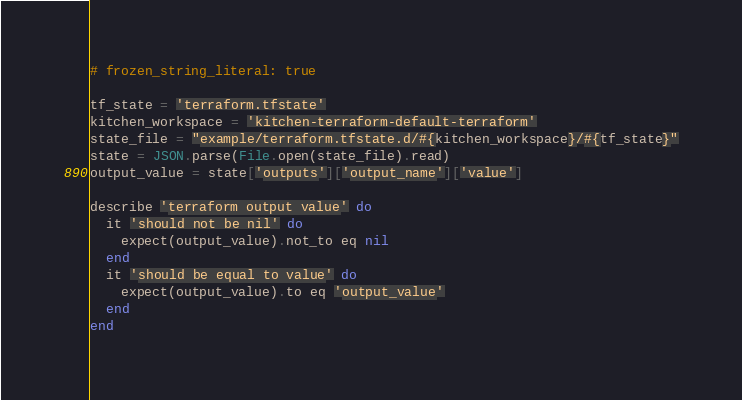Convert code to text. <code><loc_0><loc_0><loc_500><loc_500><_Ruby_># frozen_string_literal: true

tf_state = 'terraform.tfstate'
kitchen_workspace = 'kitchen-terraform-default-terraform'
state_file = "example/terraform.tfstate.d/#{kitchen_workspace}/#{tf_state}"
state = JSON.parse(File.open(state_file).read)
output_value = state['outputs']['output_name']['value']

describe 'terraform output value' do
  it 'should not be nil' do
    expect(output_value).not_to eq nil
  end
  it 'should be equal to value' do
    expect(output_value).to eq 'output_value'
  end
end
</code> 